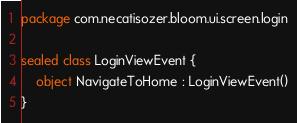<code> <loc_0><loc_0><loc_500><loc_500><_Kotlin_>package com.necatisozer.bloom.ui.screen.login

sealed class LoginViewEvent {
    object NavigateToHome : LoginViewEvent()
}
</code> 